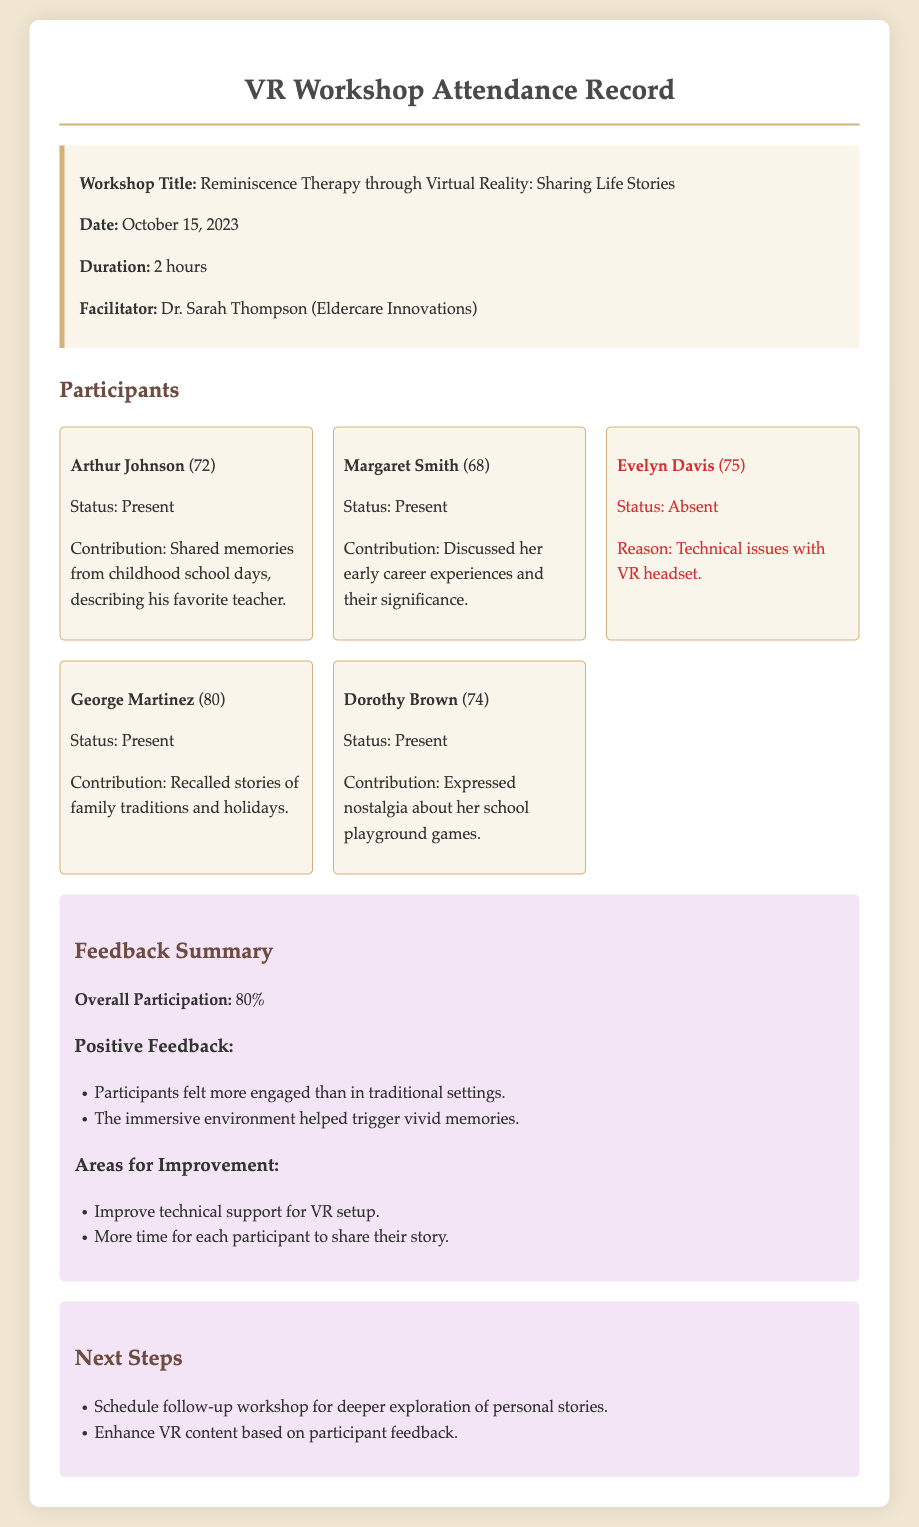What is the workshop title? The title of the workshop is stated in the document clearly.
Answer: Reminiscence Therapy through Virtual Reality: Sharing Life Stories Who was the facilitator of the workshop? The facilitator's name is mentioned in the document.
Answer: Dr. Sarah Thompson What was the date of the workshop? The date can be found in the workshop details section of the document.
Answer: October 15, 2023 How many participants were present? Count the participants listed as present in the document.
Answer: 4 What percentage of overall participation was recorded? The overall participation percentage is summarized in the feedback section.
Answer: 80% What was the reason for Evelyn Davis' absence? The document states the reason for her absence directly.
Answer: Technical issues with VR headset What is one area for improvement mentioned in the feedback? The feedback section provides areas for improvement.
Answer: Improve technical support for VR setup What did Dorothy Brown express nostalgia about? The contributions of each participant include what they shared during the workshop.
Answer: School playground games What is one of the next steps proposed after the workshop? The next steps are outlined in a dedicated section of the document.
Answer: Schedule follow-up workshop for deeper exploration of personal stories 